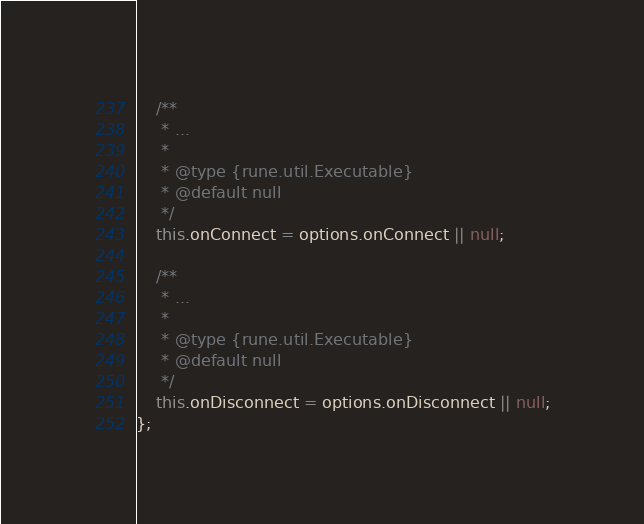<code> <loc_0><loc_0><loc_500><loc_500><_JavaScript_>    /**
     * ...
     *
     * @type {rune.util.Executable}
     * @default null
     */
    this.onConnect = options.onConnect || null;
    
    /**
     * ...
     *
     * @type {rune.util.Executable}
     * @default null
     */
    this.onDisconnect = options.onDisconnect || null;
};</code> 